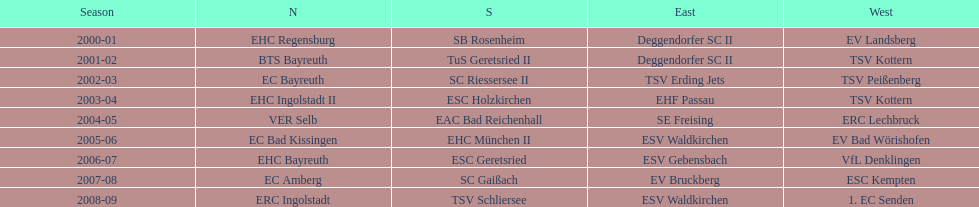The last team to win the west? 1. EC Senden. 